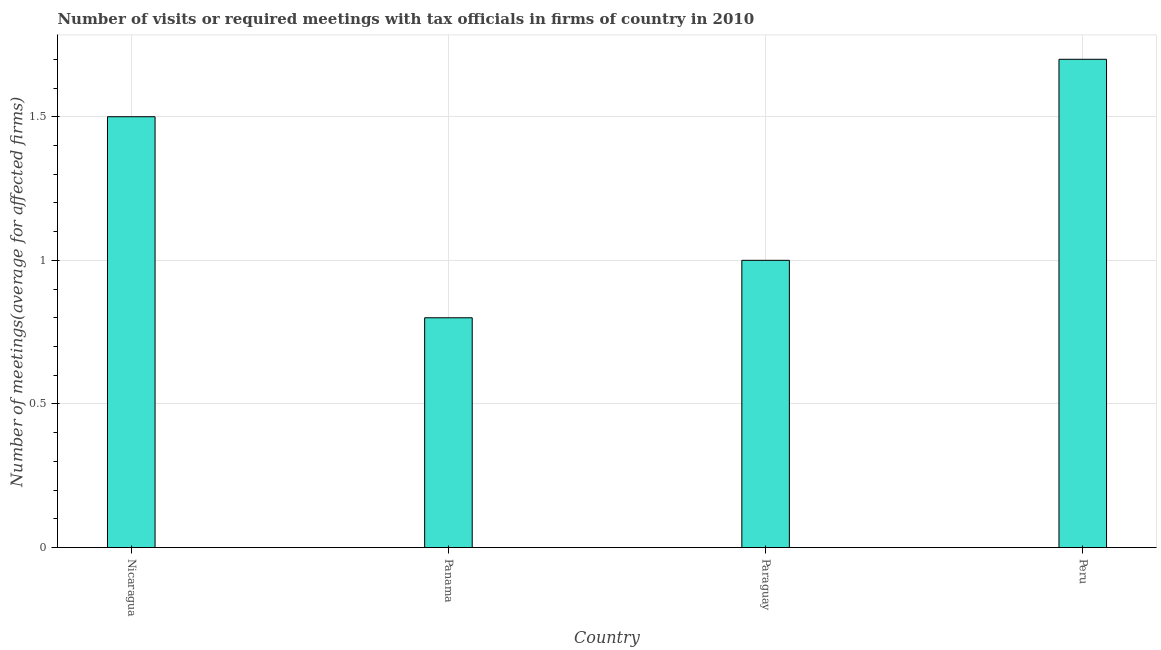Does the graph contain any zero values?
Give a very brief answer. No. Does the graph contain grids?
Give a very brief answer. Yes. What is the title of the graph?
Offer a very short reply. Number of visits or required meetings with tax officials in firms of country in 2010. What is the label or title of the X-axis?
Your answer should be very brief. Country. What is the label or title of the Y-axis?
Your response must be concise. Number of meetings(average for affected firms). In which country was the number of required meetings with tax officials maximum?
Offer a terse response. Peru. In which country was the number of required meetings with tax officials minimum?
Your response must be concise. Panama. What is the sum of the number of required meetings with tax officials?
Provide a succinct answer. 5. What is the difference between the number of required meetings with tax officials in Panama and Peru?
Keep it short and to the point. -0.9. What is the average number of required meetings with tax officials per country?
Your response must be concise. 1.25. What is the ratio of the number of required meetings with tax officials in Nicaragua to that in Panama?
Provide a short and direct response. 1.88. What is the difference between the highest and the second highest number of required meetings with tax officials?
Offer a very short reply. 0.2. Is the sum of the number of required meetings with tax officials in Panama and Peru greater than the maximum number of required meetings with tax officials across all countries?
Provide a succinct answer. Yes. In how many countries, is the number of required meetings with tax officials greater than the average number of required meetings with tax officials taken over all countries?
Offer a very short reply. 2. How many bars are there?
Ensure brevity in your answer.  4. Are all the bars in the graph horizontal?
Make the answer very short. No. How many countries are there in the graph?
Keep it short and to the point. 4. What is the difference between two consecutive major ticks on the Y-axis?
Offer a very short reply. 0.5. What is the Number of meetings(average for affected firms) in Nicaragua?
Your answer should be very brief. 1.5. What is the Number of meetings(average for affected firms) in Panama?
Offer a very short reply. 0.8. What is the Number of meetings(average for affected firms) in Paraguay?
Make the answer very short. 1. What is the Number of meetings(average for affected firms) in Peru?
Give a very brief answer. 1.7. What is the difference between the Number of meetings(average for affected firms) in Nicaragua and Panama?
Provide a short and direct response. 0.7. What is the difference between the Number of meetings(average for affected firms) in Panama and Paraguay?
Your response must be concise. -0.2. What is the difference between the Number of meetings(average for affected firms) in Panama and Peru?
Provide a short and direct response. -0.9. What is the ratio of the Number of meetings(average for affected firms) in Nicaragua to that in Panama?
Keep it short and to the point. 1.88. What is the ratio of the Number of meetings(average for affected firms) in Nicaragua to that in Paraguay?
Your answer should be very brief. 1.5. What is the ratio of the Number of meetings(average for affected firms) in Nicaragua to that in Peru?
Provide a short and direct response. 0.88. What is the ratio of the Number of meetings(average for affected firms) in Panama to that in Paraguay?
Offer a terse response. 0.8. What is the ratio of the Number of meetings(average for affected firms) in Panama to that in Peru?
Keep it short and to the point. 0.47. What is the ratio of the Number of meetings(average for affected firms) in Paraguay to that in Peru?
Keep it short and to the point. 0.59. 